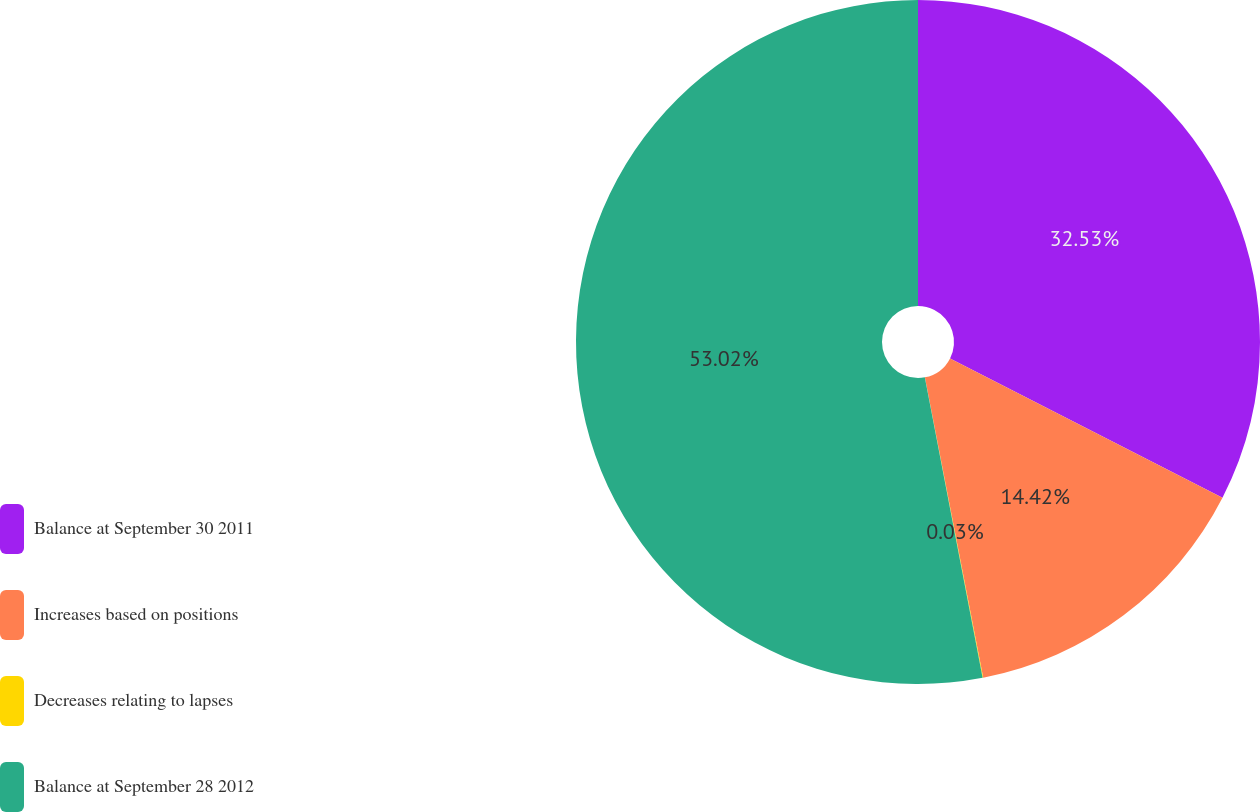Convert chart to OTSL. <chart><loc_0><loc_0><loc_500><loc_500><pie_chart><fcel>Balance at September 30 2011<fcel>Increases based on positions<fcel>Decreases relating to lapses<fcel>Balance at September 28 2012<nl><fcel>32.53%<fcel>14.42%<fcel>0.03%<fcel>53.03%<nl></chart> 